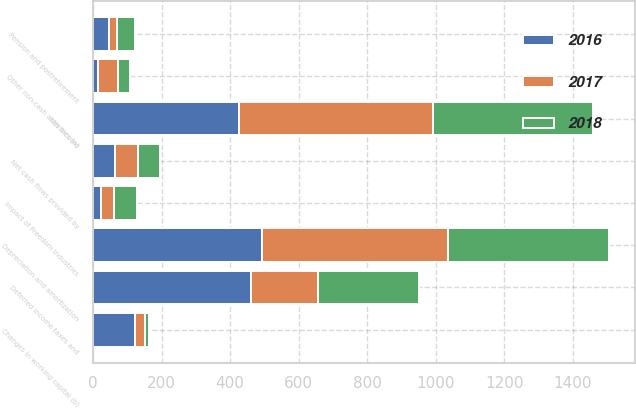Convert chart. <chart><loc_0><loc_0><loc_500><loc_500><stacked_bar_chart><ecel><fcel>Net income<fcel>Depreciation and amortization<fcel>Deferred income taxes and<fcel>Other non-cash activities (a)<fcel>Changes in working capital (b)<fcel>Pension and postretirement<fcel>Impact of Freedom Industries<fcel>Net cash flows provided by<nl><fcel>2017<fcel>565<fcel>545<fcel>195<fcel>56<fcel>30<fcel>22<fcel>40<fcel>65<nl><fcel>2016<fcel>426<fcel>492<fcel>462<fcel>16<fcel>123<fcel>48<fcel>22<fcel>65<nl><fcel>2018<fcel>468<fcel>470<fcel>295<fcel>35<fcel>9<fcel>53<fcel>65<fcel>65<nl></chart> 